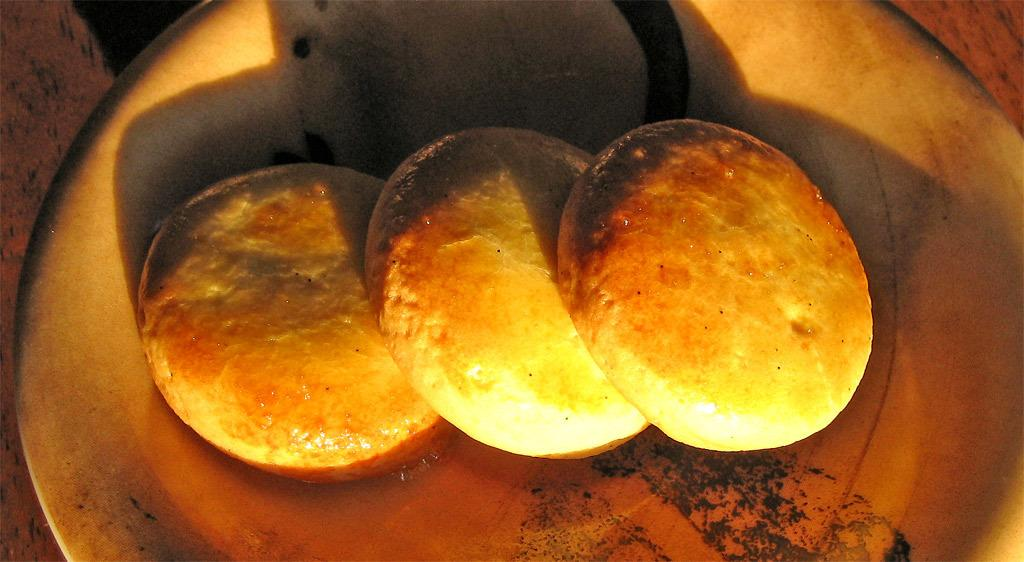What is the main subject of the image? There is a food item in the image. How is the food item presented in the image? The food item is in a plate. Where is the plate with the food item located? The plate is placed on a table. How many horses can be seen drinking from the sink in the image? There are no horses or sinks present in the image. 